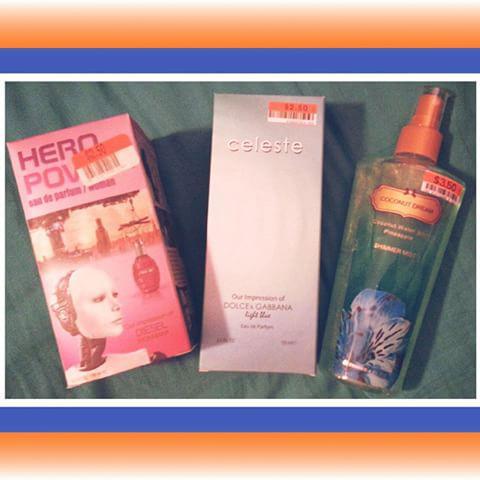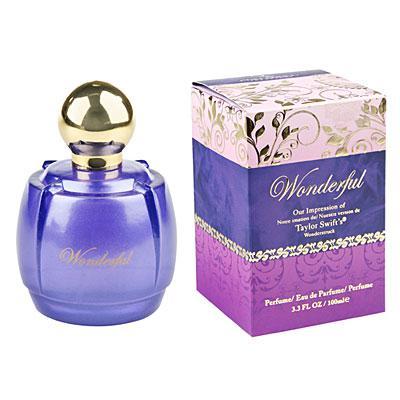The first image is the image on the left, the second image is the image on the right. Given the left and right images, does the statement "An image shows exactly one fragrance standing to the right of its box." hold true? Answer yes or no. No. The first image is the image on the left, the second image is the image on the right. Considering the images on both sides, is "There is exactly one perfume bottle in the right image." valid? Answer yes or no. Yes. 